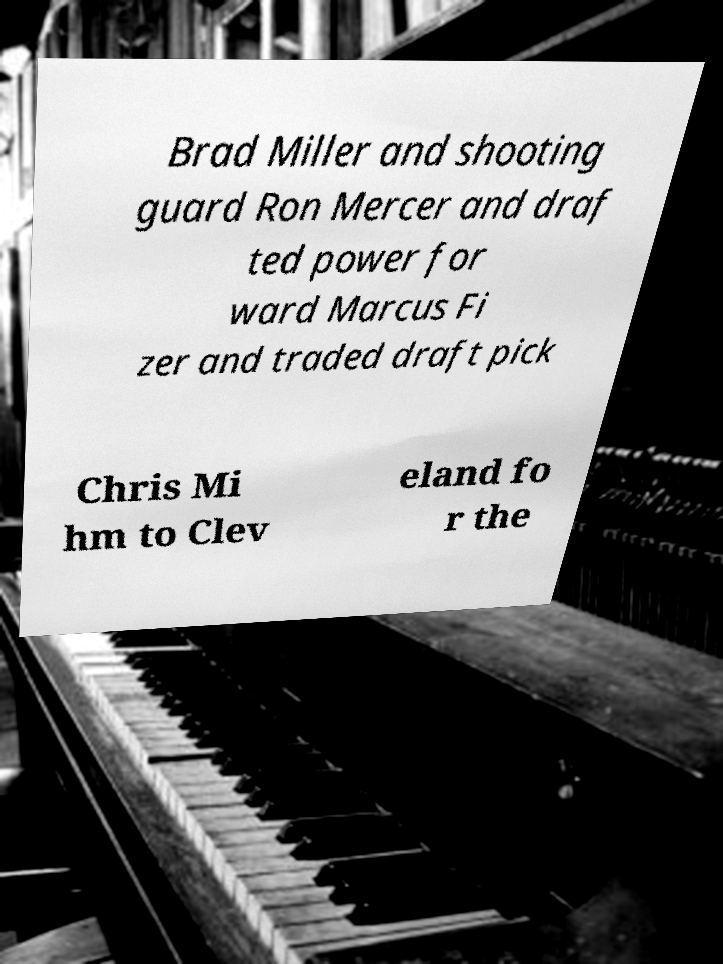Please read and relay the text visible in this image. What does it say? Brad Miller and shooting guard Ron Mercer and draf ted power for ward Marcus Fi zer and traded draft pick Chris Mi hm to Clev eland fo r the 